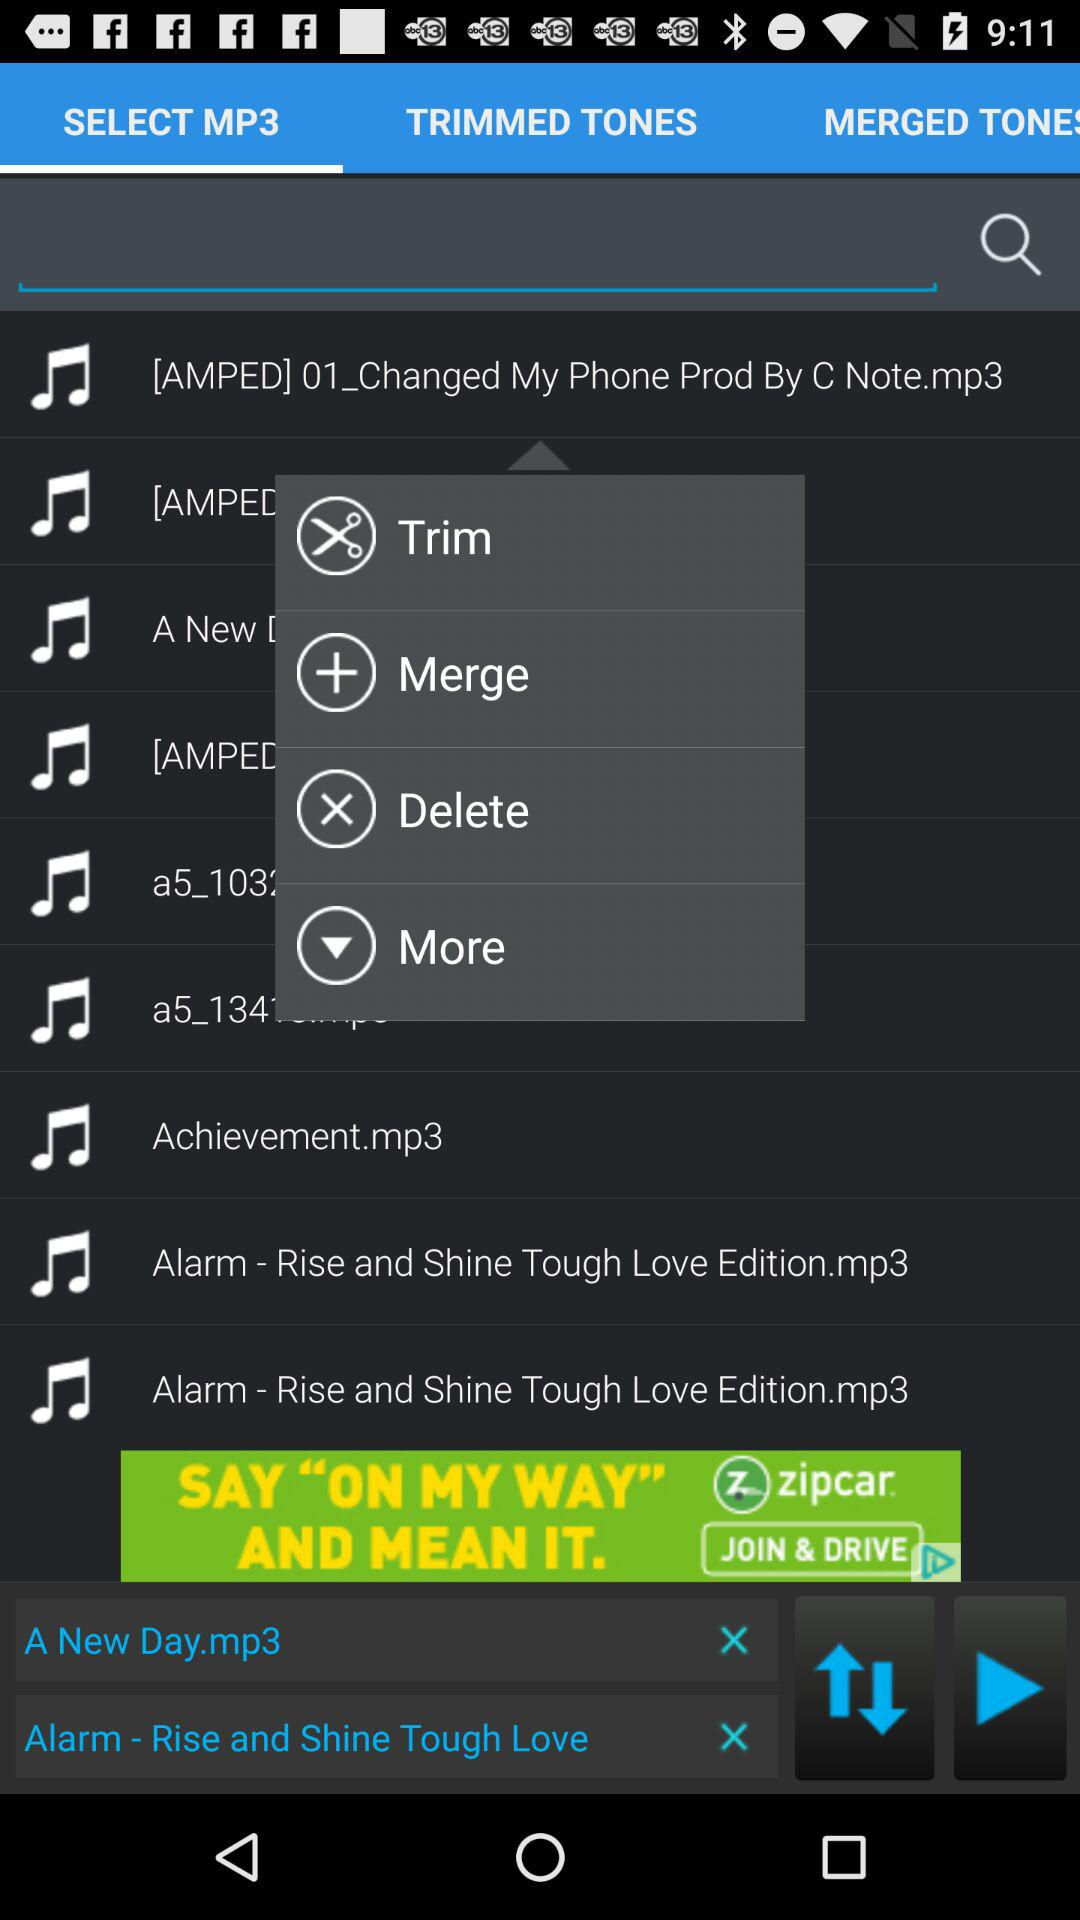What is the selected tab? The selected tab is "SELECT MP3". 